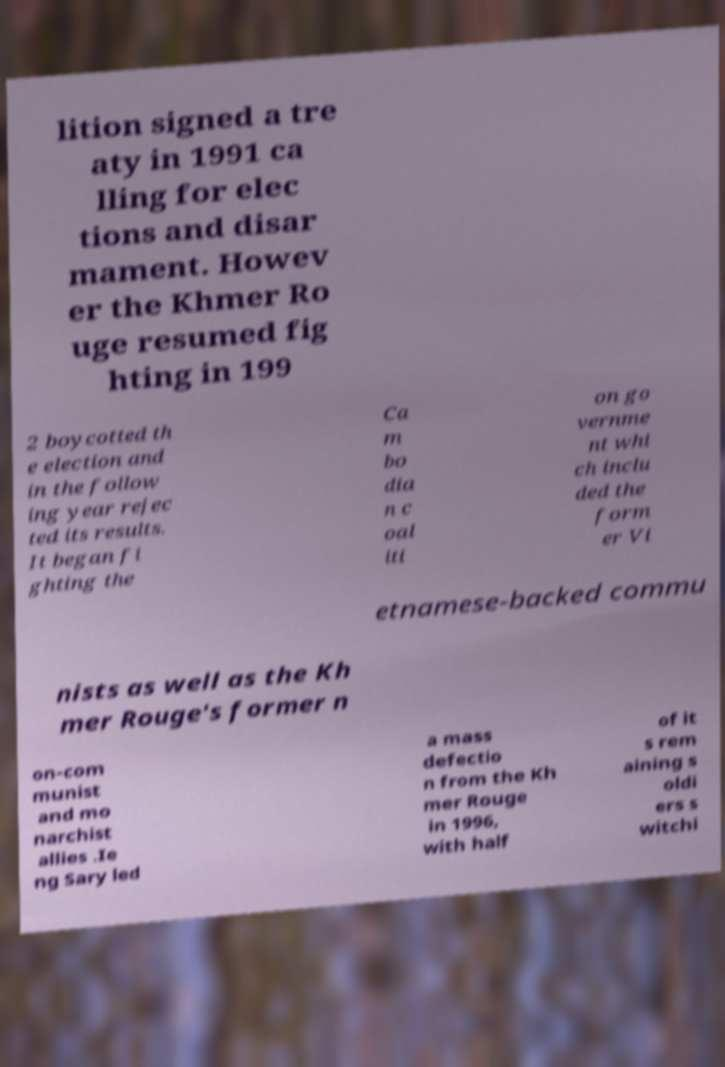For documentation purposes, I need the text within this image transcribed. Could you provide that? lition signed a tre aty in 1991 ca lling for elec tions and disar mament. Howev er the Khmer Ro uge resumed fig hting in 199 2 boycotted th e election and in the follow ing year rejec ted its results. It began fi ghting the Ca m bo dia n c oal iti on go vernme nt whi ch inclu ded the form er Vi etnamese-backed commu nists as well as the Kh mer Rouge's former n on-com munist and mo narchist allies .Ie ng Sary led a mass defectio n from the Kh mer Rouge in 1996, with half of it s rem aining s oldi ers s witchi 